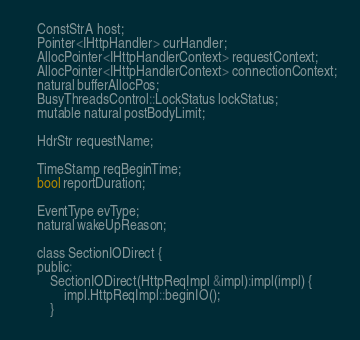<code> <loc_0><loc_0><loc_500><loc_500><_C_>	ConstStrA host;
	Pointer<IHttpHandler> curHandler;
	AllocPointer<IHttpHandlerContext> requestContext;
	AllocPointer<IHttpHandlerContext> connectionContext;
	natural bufferAllocPos;
	BusyThreadsControl::LockStatus lockStatus;
	mutable natural postBodyLimit;

	HdrStr requestName;

	TimeStamp reqBeginTime;
	bool reportDuration;

	EventType evType;
	natural wakeUpReason;

	class SectionIODirect {
	public:
		SectionIODirect(HttpReqImpl &impl):impl(impl) {
			impl.HttpReqImpl::beginIO();
		}</code> 